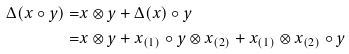<formula> <loc_0><loc_0><loc_500><loc_500>\Delta ( x \circ y ) = & x \otimes y + \Delta ( x ) \circ y \\ = & x \otimes y + x _ { ( 1 ) } \circ y \otimes x _ { ( 2 ) } + x _ { ( 1 ) } \otimes x _ { ( 2 ) } \circ y \\</formula> 